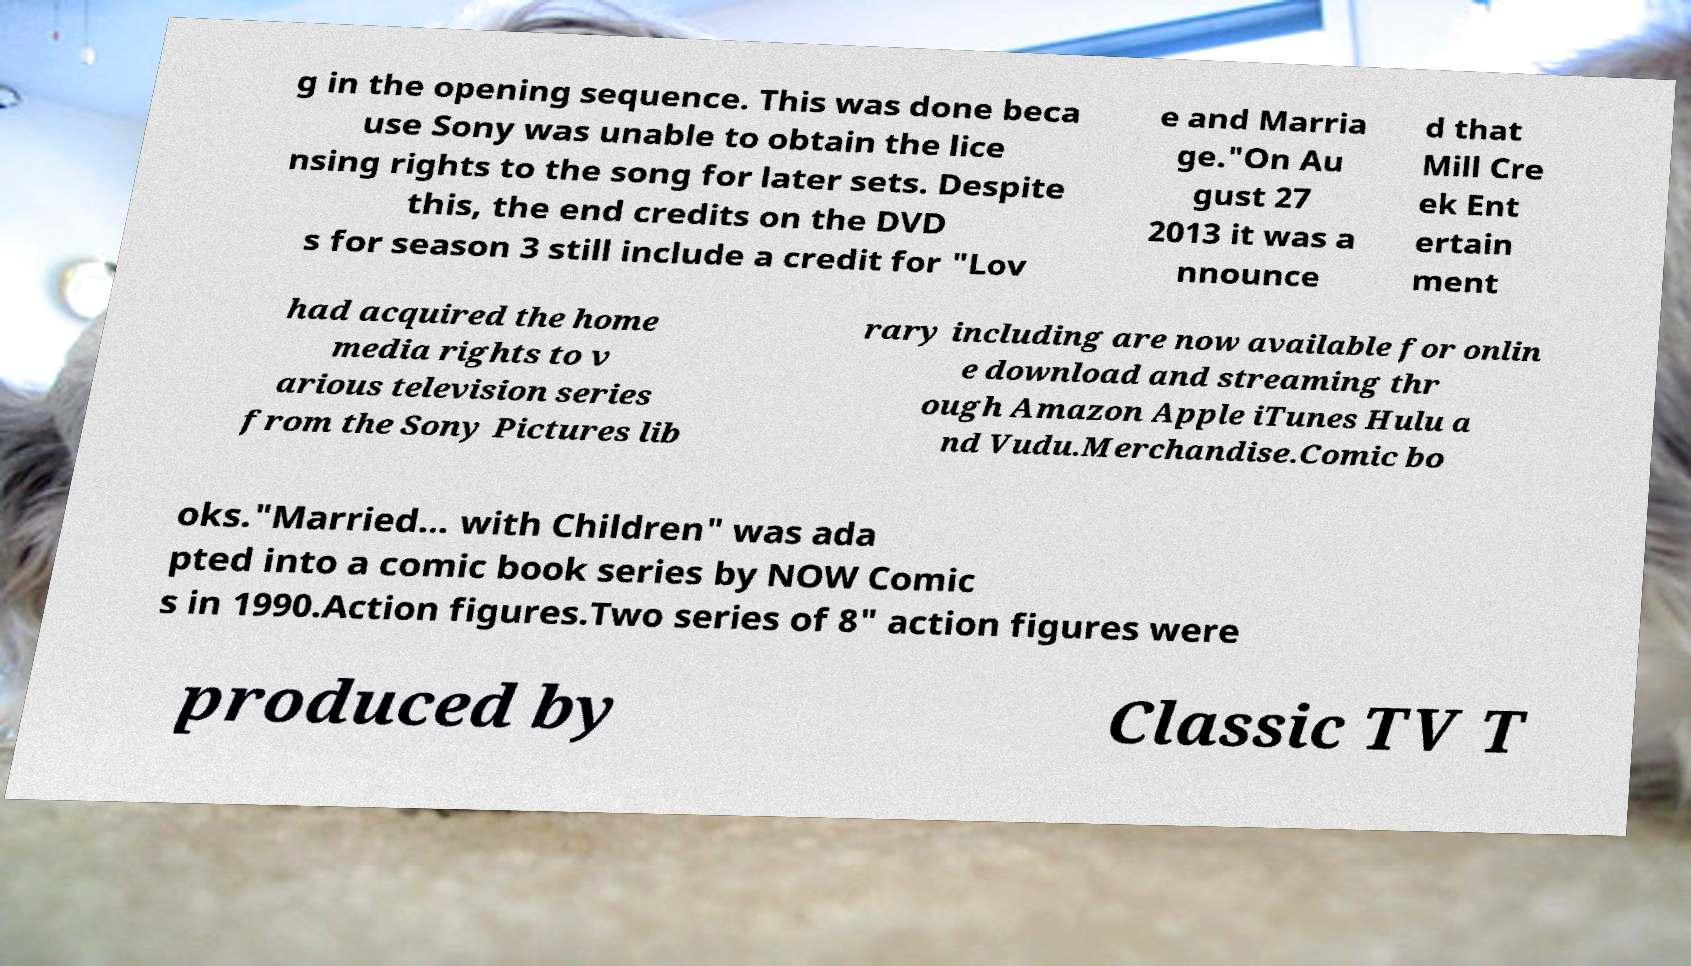Please read and relay the text visible in this image. What does it say? g in the opening sequence. This was done beca use Sony was unable to obtain the lice nsing rights to the song for later sets. Despite this, the end credits on the DVD s for season 3 still include a credit for "Lov e and Marria ge."On Au gust 27 2013 it was a nnounce d that Mill Cre ek Ent ertain ment had acquired the home media rights to v arious television series from the Sony Pictures lib rary including are now available for onlin e download and streaming thr ough Amazon Apple iTunes Hulu a nd Vudu.Merchandise.Comic bo oks."Married... with Children" was ada pted into a comic book series by NOW Comic s in 1990.Action figures.Two series of 8" action figures were produced by Classic TV T 